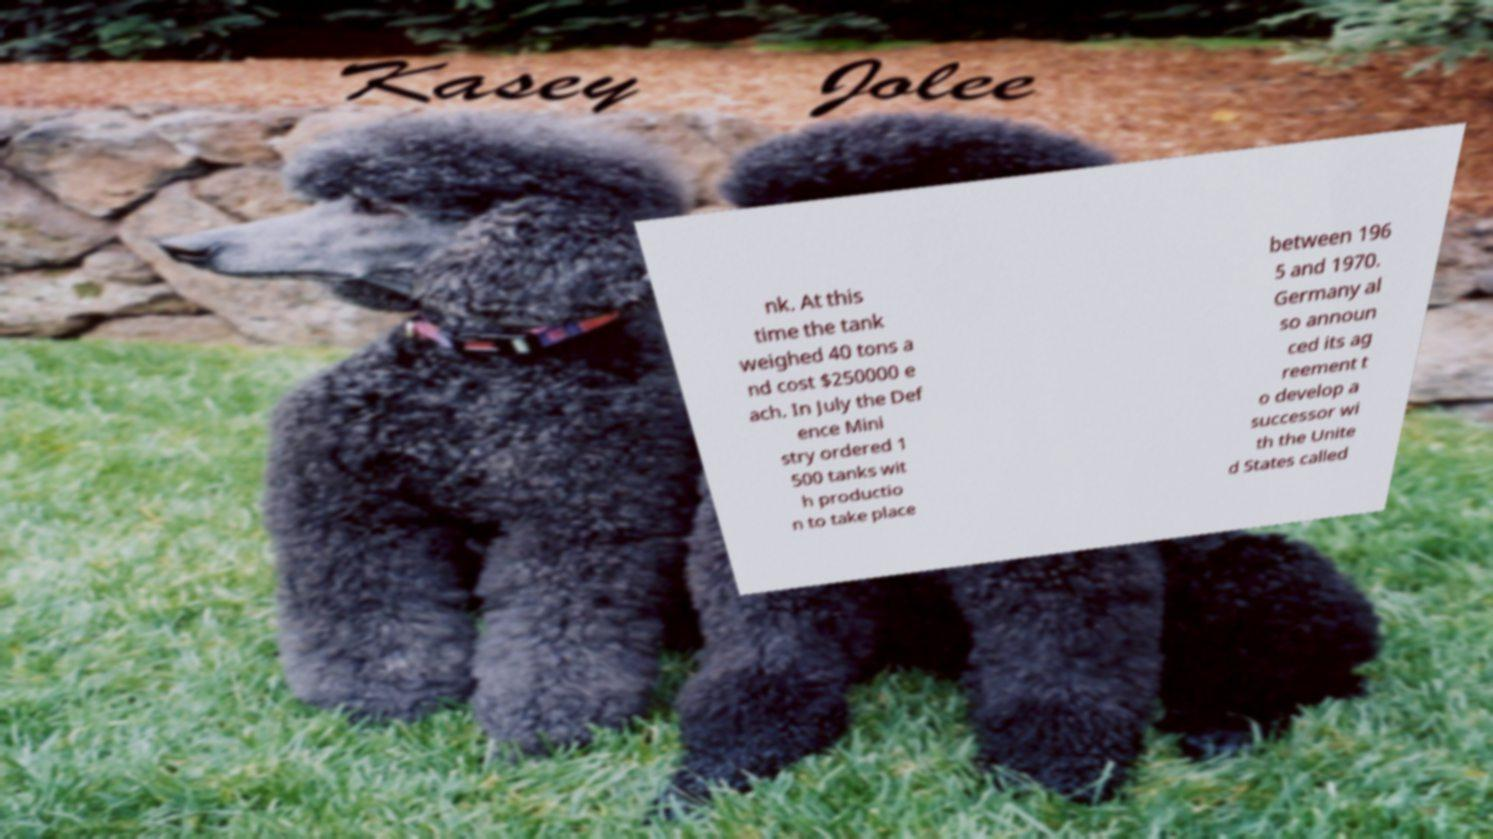Please identify and transcribe the text found in this image. nk. At this time the tank weighed 40 tons a nd cost $250000 e ach. In July the Def ence Mini stry ordered 1 500 tanks wit h productio n to take place between 196 5 and 1970. Germany al so announ ced its ag reement t o develop a successor wi th the Unite d States called 